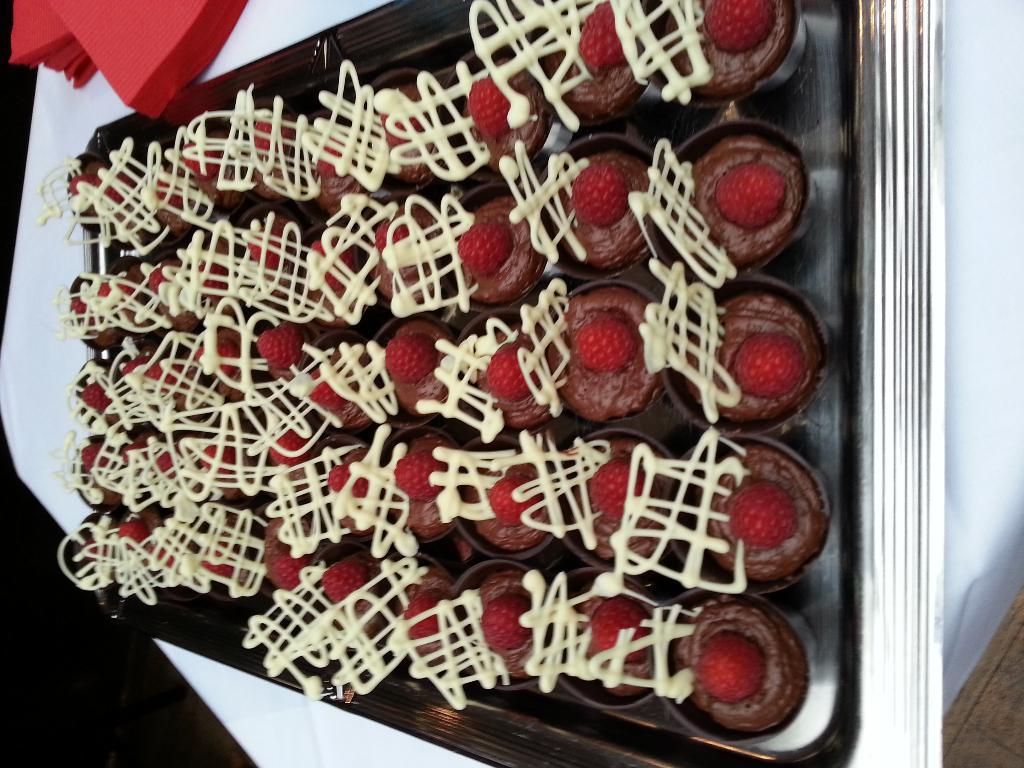What type of food can be seen in the image? There are cupcakes in the image. How are the cupcakes arranged or positioned? The cupcakes are placed on a plate. Where is the plate with the cupcakes located? The plate with the cupcakes is placed on a table. What type of baseball equipment can be seen in the image? There is no baseball equipment present in the image. How many chickens are visible in the image? There are no chickens visible in the image. 